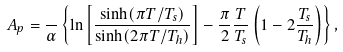<formula> <loc_0><loc_0><loc_500><loc_500>A _ { p } = \frac { } { \alpha } \left \{ \ln \left [ \frac { \sinh ( \pi T / T _ { s } ) } { \sinh ( 2 \pi T / T _ { h } ) } \right ] - \frac { \pi } { 2 } \frac { T } { T _ { s } } \left ( 1 - 2 \frac { T _ { s } } { T _ { h } } \right ) \right \} ,</formula> 